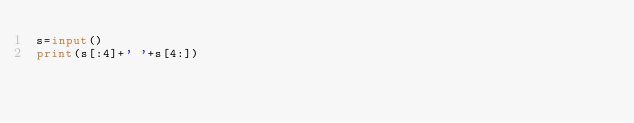<code> <loc_0><loc_0><loc_500><loc_500><_Python_>s=input()
print(s[:4]+' '+s[4:])</code> 